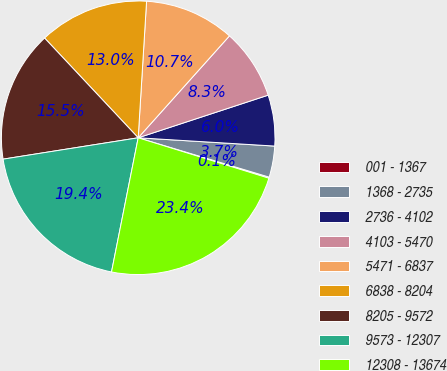Convert chart. <chart><loc_0><loc_0><loc_500><loc_500><pie_chart><fcel>001 - 1367<fcel>1368 - 2735<fcel>2736 - 4102<fcel>4103 - 5470<fcel>5471 - 6837<fcel>6838 - 8204<fcel>8205 - 9572<fcel>9573 - 12307<fcel>12308 - 13674<nl><fcel>0.13%<fcel>3.68%<fcel>6.01%<fcel>8.33%<fcel>10.65%<fcel>12.97%<fcel>15.5%<fcel>19.38%<fcel>23.35%<nl></chart> 